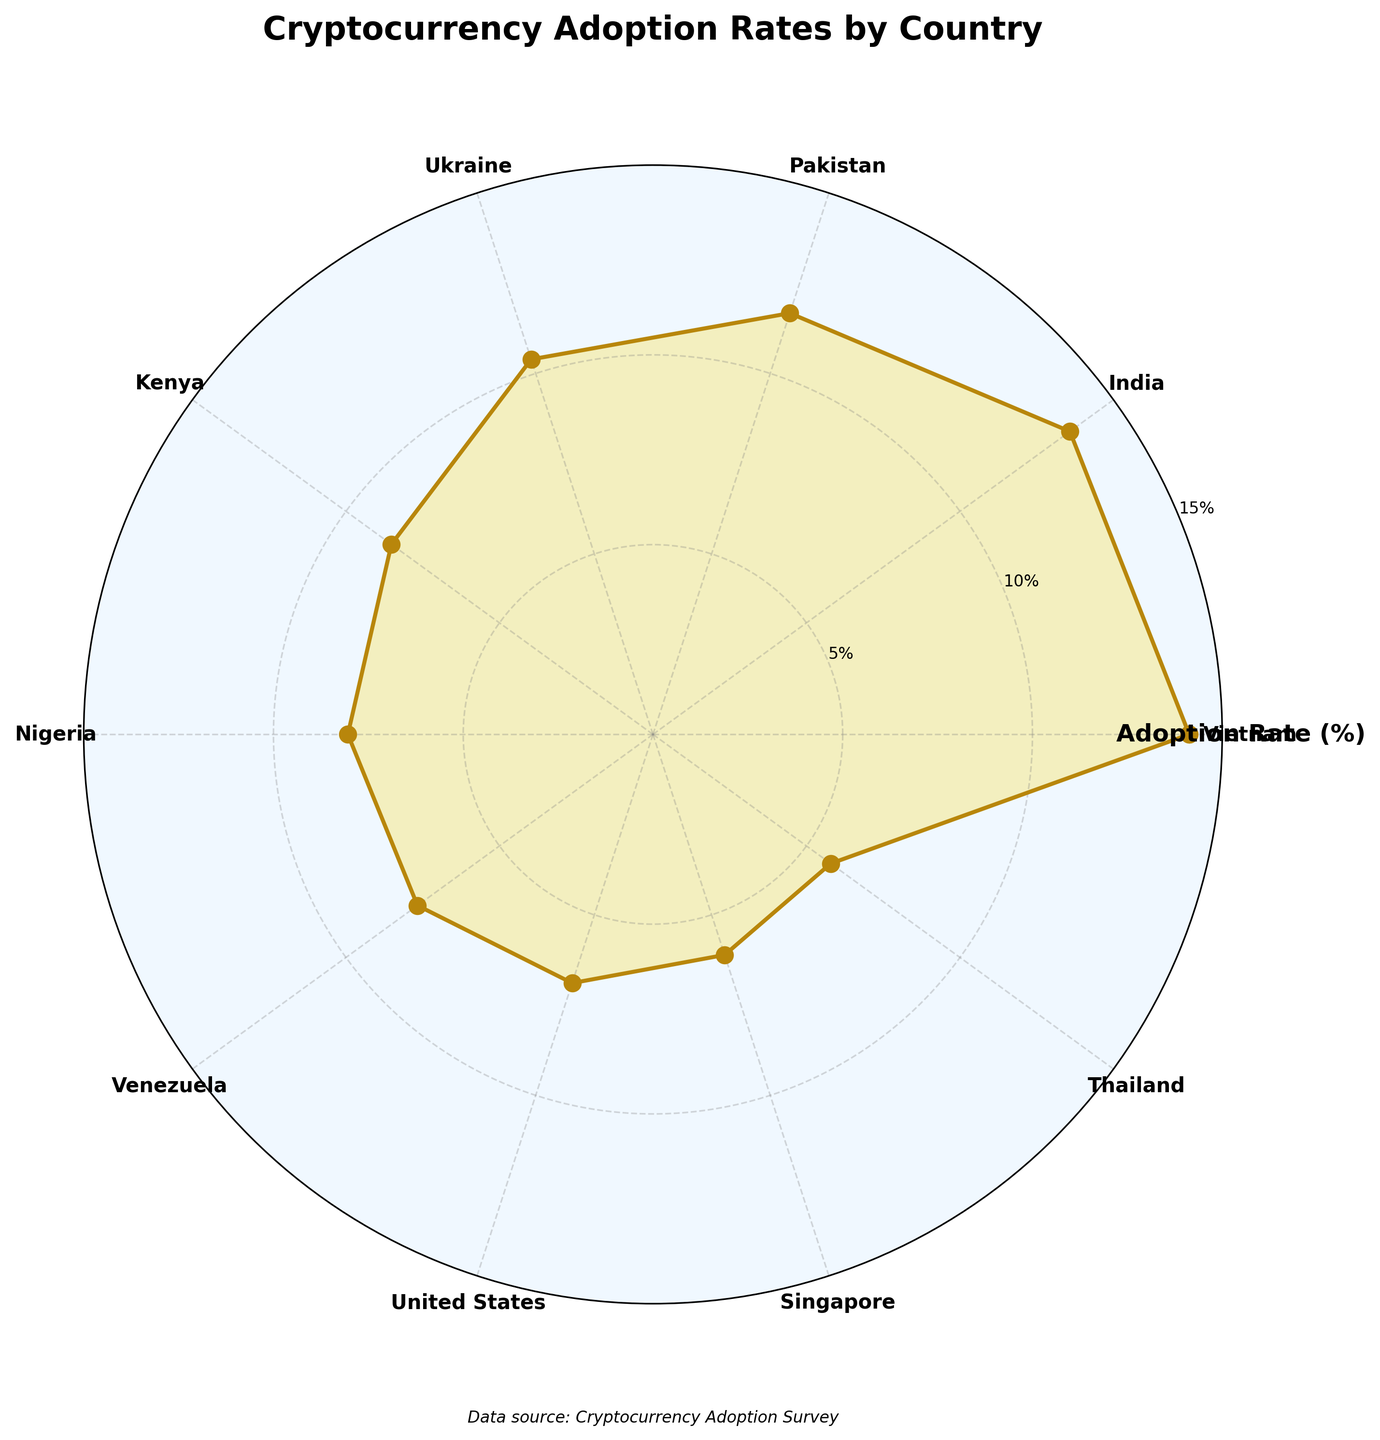How many countries are displayed in the chart? The chart has 10 labeled segments, each corresponding to a different country on the polar area chart.
Answer: 10 What's the title of the chart? The title is displayed at the top center of the chart.
Answer: Cryptocurrency Adoption Rates by Country Which country has the highest cryptocurrency adoption rate? The segment with the highest value on the radial dimension is for Vietnam at 14.13%.
Answer: Vietnam How does the adoption rate of the United States compare to Singapore? The angle corresponding to the United States shows an adoption rate of 6.89%, while Singapore has an adoption rate of 6.11%, so the United States has a higher rate.
Answer: The United States has a higher rate What is the difference in adoption rates between Pakistan and Kenya? Pakistan's adoption rate is 11.67% and Kenya's is 8.52%. The difference is 11.67% - 8.52%.
Answer: 3.15% Which country has the smallest adoption rate, and what is that rate? The smallest segment corresponds to Thailand, which has an adoption rate of 5.79%.
Answer: Thailand, 5.79% What is the average adoption rate across all countries listed? Sum all the adoption rates and divide by the number of countries: (14.13% + 13.58% + 11.67% + 10.39% + 8.52% + 8.04% + 7.67% + 6.89% + 6.11% + 5.79%) / 10.
Answer: 9.58% Are there any countries with an adoption rate between 5% and 10%? The segments for Kenya, Nigeria, Venezuela, United States, Singapore, and Thailand all fall within this range.
Answer: Yes How does the adoption rate in Venezuela compare to Pakistan? Venezuela has an adoption rate of 7.67%, and Pakistan has an adoption rate of 11.67%. Comparatively, Pakistan has a higher adoption rate.
Answer: Pakistan has a higher rate What is the sum of adoption rates for the top three countries? The top three countries are Vietnam (14.13%), India (13.58%), and Pakistan (11.67%). Sum them: 14.13% + 13.58% + 11.67%.
Answer: 39.38% 